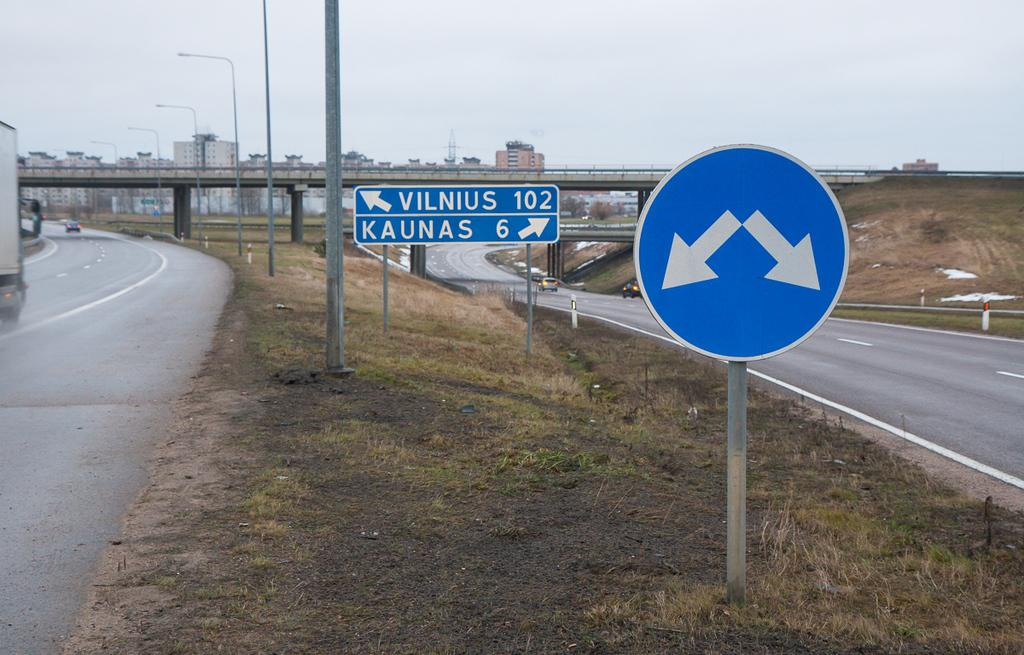<image>
Provide a brief description of the given image. A road sign points the way to locations named Vilnius and Kaunas. 